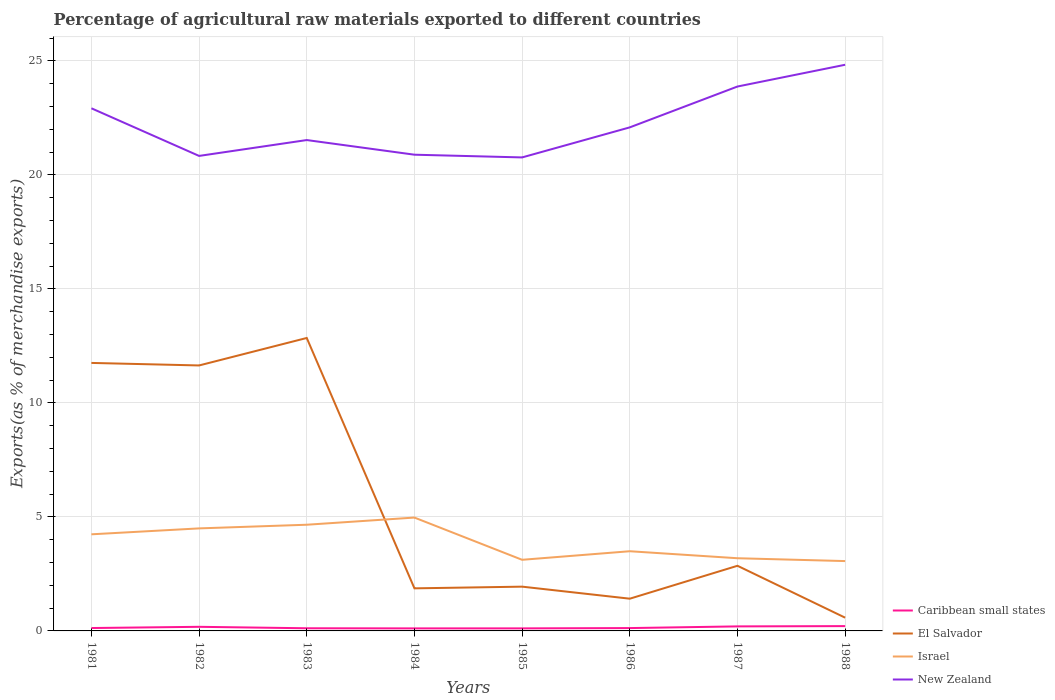Does the line corresponding to Caribbean small states intersect with the line corresponding to Israel?
Make the answer very short. No. Across all years, what is the maximum percentage of exports to different countries in Caribbean small states?
Provide a succinct answer. 0.11. What is the total percentage of exports to different countries in Israel in the graph?
Your answer should be compact. 1.43. What is the difference between the highest and the second highest percentage of exports to different countries in El Salvador?
Provide a short and direct response. 12.27. How many lines are there?
Provide a short and direct response. 4. How many legend labels are there?
Make the answer very short. 4. How are the legend labels stacked?
Keep it short and to the point. Vertical. What is the title of the graph?
Your response must be concise. Percentage of agricultural raw materials exported to different countries. Does "United Arab Emirates" appear as one of the legend labels in the graph?
Your answer should be very brief. No. What is the label or title of the Y-axis?
Make the answer very short. Exports(as % of merchandise exports). What is the Exports(as % of merchandise exports) of Caribbean small states in 1981?
Offer a terse response. 0.13. What is the Exports(as % of merchandise exports) of El Salvador in 1981?
Keep it short and to the point. 11.76. What is the Exports(as % of merchandise exports) in Israel in 1981?
Your answer should be very brief. 4.24. What is the Exports(as % of merchandise exports) of New Zealand in 1981?
Make the answer very short. 22.92. What is the Exports(as % of merchandise exports) of Caribbean small states in 1982?
Ensure brevity in your answer.  0.18. What is the Exports(as % of merchandise exports) in El Salvador in 1982?
Make the answer very short. 11.64. What is the Exports(as % of merchandise exports) in Israel in 1982?
Offer a very short reply. 4.5. What is the Exports(as % of merchandise exports) in New Zealand in 1982?
Provide a succinct answer. 20.84. What is the Exports(as % of merchandise exports) in Caribbean small states in 1983?
Your answer should be very brief. 0.12. What is the Exports(as % of merchandise exports) in El Salvador in 1983?
Offer a very short reply. 12.85. What is the Exports(as % of merchandise exports) in Israel in 1983?
Offer a very short reply. 4.66. What is the Exports(as % of merchandise exports) of New Zealand in 1983?
Ensure brevity in your answer.  21.53. What is the Exports(as % of merchandise exports) in Caribbean small states in 1984?
Keep it short and to the point. 0.11. What is the Exports(as % of merchandise exports) in El Salvador in 1984?
Ensure brevity in your answer.  1.87. What is the Exports(as % of merchandise exports) of Israel in 1984?
Make the answer very short. 4.97. What is the Exports(as % of merchandise exports) of New Zealand in 1984?
Provide a short and direct response. 20.89. What is the Exports(as % of merchandise exports) of Caribbean small states in 1985?
Keep it short and to the point. 0.11. What is the Exports(as % of merchandise exports) in El Salvador in 1985?
Make the answer very short. 1.94. What is the Exports(as % of merchandise exports) in Israel in 1985?
Give a very brief answer. 3.12. What is the Exports(as % of merchandise exports) in New Zealand in 1985?
Provide a succinct answer. 20.77. What is the Exports(as % of merchandise exports) of Caribbean small states in 1986?
Provide a succinct answer. 0.12. What is the Exports(as % of merchandise exports) of El Salvador in 1986?
Your answer should be very brief. 1.41. What is the Exports(as % of merchandise exports) in Israel in 1986?
Give a very brief answer. 3.5. What is the Exports(as % of merchandise exports) of New Zealand in 1986?
Your answer should be very brief. 22.09. What is the Exports(as % of merchandise exports) in Caribbean small states in 1987?
Make the answer very short. 0.2. What is the Exports(as % of merchandise exports) in El Salvador in 1987?
Give a very brief answer. 2.86. What is the Exports(as % of merchandise exports) in Israel in 1987?
Give a very brief answer. 3.19. What is the Exports(as % of merchandise exports) of New Zealand in 1987?
Ensure brevity in your answer.  23.88. What is the Exports(as % of merchandise exports) of Caribbean small states in 1988?
Your answer should be very brief. 0.21. What is the Exports(as % of merchandise exports) of El Salvador in 1988?
Offer a very short reply. 0.58. What is the Exports(as % of merchandise exports) in Israel in 1988?
Offer a very short reply. 3.06. What is the Exports(as % of merchandise exports) of New Zealand in 1988?
Offer a very short reply. 24.83. Across all years, what is the maximum Exports(as % of merchandise exports) in Caribbean small states?
Provide a succinct answer. 0.21. Across all years, what is the maximum Exports(as % of merchandise exports) in El Salvador?
Your answer should be very brief. 12.85. Across all years, what is the maximum Exports(as % of merchandise exports) in Israel?
Your answer should be very brief. 4.97. Across all years, what is the maximum Exports(as % of merchandise exports) of New Zealand?
Your answer should be compact. 24.83. Across all years, what is the minimum Exports(as % of merchandise exports) in Caribbean small states?
Offer a very short reply. 0.11. Across all years, what is the minimum Exports(as % of merchandise exports) in El Salvador?
Your response must be concise. 0.58. Across all years, what is the minimum Exports(as % of merchandise exports) in Israel?
Ensure brevity in your answer.  3.06. Across all years, what is the minimum Exports(as % of merchandise exports) of New Zealand?
Your answer should be compact. 20.77. What is the total Exports(as % of merchandise exports) in Caribbean small states in the graph?
Offer a very short reply. 1.18. What is the total Exports(as % of merchandise exports) of El Salvador in the graph?
Ensure brevity in your answer.  44.91. What is the total Exports(as % of merchandise exports) of Israel in the graph?
Ensure brevity in your answer.  31.23. What is the total Exports(as % of merchandise exports) in New Zealand in the graph?
Make the answer very short. 177.75. What is the difference between the Exports(as % of merchandise exports) of Caribbean small states in 1981 and that in 1982?
Offer a terse response. -0.05. What is the difference between the Exports(as % of merchandise exports) in El Salvador in 1981 and that in 1982?
Give a very brief answer. 0.11. What is the difference between the Exports(as % of merchandise exports) of Israel in 1981 and that in 1982?
Keep it short and to the point. -0.26. What is the difference between the Exports(as % of merchandise exports) of New Zealand in 1981 and that in 1982?
Your answer should be very brief. 2.09. What is the difference between the Exports(as % of merchandise exports) in Caribbean small states in 1981 and that in 1983?
Make the answer very short. 0.01. What is the difference between the Exports(as % of merchandise exports) of El Salvador in 1981 and that in 1983?
Make the answer very short. -1.09. What is the difference between the Exports(as % of merchandise exports) of Israel in 1981 and that in 1983?
Your answer should be compact. -0.42. What is the difference between the Exports(as % of merchandise exports) in New Zealand in 1981 and that in 1983?
Ensure brevity in your answer.  1.39. What is the difference between the Exports(as % of merchandise exports) in Caribbean small states in 1981 and that in 1984?
Offer a terse response. 0.02. What is the difference between the Exports(as % of merchandise exports) of El Salvador in 1981 and that in 1984?
Your answer should be compact. 9.89. What is the difference between the Exports(as % of merchandise exports) of Israel in 1981 and that in 1984?
Your response must be concise. -0.73. What is the difference between the Exports(as % of merchandise exports) of New Zealand in 1981 and that in 1984?
Offer a terse response. 2.04. What is the difference between the Exports(as % of merchandise exports) in Caribbean small states in 1981 and that in 1985?
Provide a succinct answer. 0.02. What is the difference between the Exports(as % of merchandise exports) of El Salvador in 1981 and that in 1985?
Offer a very short reply. 9.81. What is the difference between the Exports(as % of merchandise exports) in Israel in 1981 and that in 1985?
Your answer should be compact. 1.12. What is the difference between the Exports(as % of merchandise exports) in New Zealand in 1981 and that in 1985?
Give a very brief answer. 2.15. What is the difference between the Exports(as % of merchandise exports) of Caribbean small states in 1981 and that in 1986?
Your answer should be very brief. 0. What is the difference between the Exports(as % of merchandise exports) in El Salvador in 1981 and that in 1986?
Give a very brief answer. 10.34. What is the difference between the Exports(as % of merchandise exports) of Israel in 1981 and that in 1986?
Give a very brief answer. 0.74. What is the difference between the Exports(as % of merchandise exports) in New Zealand in 1981 and that in 1986?
Offer a terse response. 0.84. What is the difference between the Exports(as % of merchandise exports) of Caribbean small states in 1981 and that in 1987?
Your answer should be very brief. -0.07. What is the difference between the Exports(as % of merchandise exports) of El Salvador in 1981 and that in 1987?
Give a very brief answer. 8.9. What is the difference between the Exports(as % of merchandise exports) in Israel in 1981 and that in 1987?
Your answer should be very brief. 1.05. What is the difference between the Exports(as % of merchandise exports) of New Zealand in 1981 and that in 1987?
Give a very brief answer. -0.95. What is the difference between the Exports(as % of merchandise exports) of Caribbean small states in 1981 and that in 1988?
Make the answer very short. -0.08. What is the difference between the Exports(as % of merchandise exports) in El Salvador in 1981 and that in 1988?
Ensure brevity in your answer.  11.17. What is the difference between the Exports(as % of merchandise exports) in Israel in 1981 and that in 1988?
Keep it short and to the point. 1.17. What is the difference between the Exports(as % of merchandise exports) in New Zealand in 1981 and that in 1988?
Make the answer very short. -1.91. What is the difference between the Exports(as % of merchandise exports) of Caribbean small states in 1982 and that in 1983?
Give a very brief answer. 0.06. What is the difference between the Exports(as % of merchandise exports) of El Salvador in 1982 and that in 1983?
Offer a terse response. -1.21. What is the difference between the Exports(as % of merchandise exports) of Israel in 1982 and that in 1983?
Your response must be concise. -0.16. What is the difference between the Exports(as % of merchandise exports) in New Zealand in 1982 and that in 1983?
Offer a terse response. -0.7. What is the difference between the Exports(as % of merchandise exports) of Caribbean small states in 1982 and that in 1984?
Your response must be concise. 0.07. What is the difference between the Exports(as % of merchandise exports) in El Salvador in 1982 and that in 1984?
Ensure brevity in your answer.  9.78. What is the difference between the Exports(as % of merchandise exports) of Israel in 1982 and that in 1984?
Give a very brief answer. -0.47. What is the difference between the Exports(as % of merchandise exports) in New Zealand in 1982 and that in 1984?
Provide a succinct answer. -0.05. What is the difference between the Exports(as % of merchandise exports) of Caribbean small states in 1982 and that in 1985?
Your answer should be compact. 0.07. What is the difference between the Exports(as % of merchandise exports) in El Salvador in 1982 and that in 1985?
Keep it short and to the point. 9.7. What is the difference between the Exports(as % of merchandise exports) of Israel in 1982 and that in 1985?
Provide a succinct answer. 1.38. What is the difference between the Exports(as % of merchandise exports) in New Zealand in 1982 and that in 1985?
Offer a very short reply. 0.07. What is the difference between the Exports(as % of merchandise exports) in Caribbean small states in 1982 and that in 1986?
Offer a very short reply. 0.06. What is the difference between the Exports(as % of merchandise exports) in El Salvador in 1982 and that in 1986?
Offer a very short reply. 10.23. What is the difference between the Exports(as % of merchandise exports) in Israel in 1982 and that in 1986?
Offer a terse response. 1. What is the difference between the Exports(as % of merchandise exports) of New Zealand in 1982 and that in 1986?
Provide a short and direct response. -1.25. What is the difference between the Exports(as % of merchandise exports) in Caribbean small states in 1982 and that in 1987?
Provide a succinct answer. -0.02. What is the difference between the Exports(as % of merchandise exports) in El Salvador in 1982 and that in 1987?
Ensure brevity in your answer.  8.79. What is the difference between the Exports(as % of merchandise exports) of Israel in 1982 and that in 1987?
Your answer should be compact. 1.31. What is the difference between the Exports(as % of merchandise exports) in New Zealand in 1982 and that in 1987?
Keep it short and to the point. -3.04. What is the difference between the Exports(as % of merchandise exports) of Caribbean small states in 1982 and that in 1988?
Offer a terse response. -0.03. What is the difference between the Exports(as % of merchandise exports) of El Salvador in 1982 and that in 1988?
Your response must be concise. 11.06. What is the difference between the Exports(as % of merchandise exports) in Israel in 1982 and that in 1988?
Your answer should be compact. 1.43. What is the difference between the Exports(as % of merchandise exports) of New Zealand in 1982 and that in 1988?
Provide a succinct answer. -4. What is the difference between the Exports(as % of merchandise exports) in Caribbean small states in 1983 and that in 1984?
Give a very brief answer. 0.01. What is the difference between the Exports(as % of merchandise exports) in El Salvador in 1983 and that in 1984?
Make the answer very short. 10.98. What is the difference between the Exports(as % of merchandise exports) of Israel in 1983 and that in 1984?
Give a very brief answer. -0.31. What is the difference between the Exports(as % of merchandise exports) in New Zealand in 1983 and that in 1984?
Keep it short and to the point. 0.64. What is the difference between the Exports(as % of merchandise exports) of Caribbean small states in 1983 and that in 1985?
Keep it short and to the point. 0. What is the difference between the Exports(as % of merchandise exports) of El Salvador in 1983 and that in 1985?
Ensure brevity in your answer.  10.91. What is the difference between the Exports(as % of merchandise exports) of Israel in 1983 and that in 1985?
Give a very brief answer. 1.54. What is the difference between the Exports(as % of merchandise exports) of New Zealand in 1983 and that in 1985?
Your response must be concise. 0.76. What is the difference between the Exports(as % of merchandise exports) in Caribbean small states in 1983 and that in 1986?
Offer a terse response. -0.01. What is the difference between the Exports(as % of merchandise exports) of El Salvador in 1983 and that in 1986?
Give a very brief answer. 11.44. What is the difference between the Exports(as % of merchandise exports) of Israel in 1983 and that in 1986?
Keep it short and to the point. 1.16. What is the difference between the Exports(as % of merchandise exports) in New Zealand in 1983 and that in 1986?
Offer a very short reply. -0.56. What is the difference between the Exports(as % of merchandise exports) of Caribbean small states in 1983 and that in 1987?
Offer a terse response. -0.08. What is the difference between the Exports(as % of merchandise exports) in El Salvador in 1983 and that in 1987?
Offer a very short reply. 9.99. What is the difference between the Exports(as % of merchandise exports) of Israel in 1983 and that in 1987?
Offer a very short reply. 1.47. What is the difference between the Exports(as % of merchandise exports) in New Zealand in 1983 and that in 1987?
Your answer should be very brief. -2.35. What is the difference between the Exports(as % of merchandise exports) of Caribbean small states in 1983 and that in 1988?
Offer a terse response. -0.09. What is the difference between the Exports(as % of merchandise exports) in El Salvador in 1983 and that in 1988?
Your response must be concise. 12.27. What is the difference between the Exports(as % of merchandise exports) in Israel in 1983 and that in 1988?
Make the answer very short. 1.59. What is the difference between the Exports(as % of merchandise exports) in New Zealand in 1983 and that in 1988?
Offer a very short reply. -3.3. What is the difference between the Exports(as % of merchandise exports) of Caribbean small states in 1984 and that in 1985?
Ensure brevity in your answer.  -0. What is the difference between the Exports(as % of merchandise exports) in El Salvador in 1984 and that in 1985?
Your answer should be compact. -0.07. What is the difference between the Exports(as % of merchandise exports) of Israel in 1984 and that in 1985?
Your answer should be compact. 1.85. What is the difference between the Exports(as % of merchandise exports) of New Zealand in 1984 and that in 1985?
Offer a very short reply. 0.12. What is the difference between the Exports(as % of merchandise exports) in Caribbean small states in 1984 and that in 1986?
Provide a succinct answer. -0.01. What is the difference between the Exports(as % of merchandise exports) in El Salvador in 1984 and that in 1986?
Your answer should be very brief. 0.45. What is the difference between the Exports(as % of merchandise exports) in Israel in 1984 and that in 1986?
Give a very brief answer. 1.48. What is the difference between the Exports(as % of merchandise exports) in New Zealand in 1984 and that in 1986?
Your response must be concise. -1.2. What is the difference between the Exports(as % of merchandise exports) in Caribbean small states in 1984 and that in 1987?
Provide a succinct answer. -0.09. What is the difference between the Exports(as % of merchandise exports) in El Salvador in 1984 and that in 1987?
Your response must be concise. -0.99. What is the difference between the Exports(as % of merchandise exports) of Israel in 1984 and that in 1987?
Provide a short and direct response. 1.78. What is the difference between the Exports(as % of merchandise exports) in New Zealand in 1984 and that in 1987?
Ensure brevity in your answer.  -2.99. What is the difference between the Exports(as % of merchandise exports) in Caribbean small states in 1984 and that in 1988?
Make the answer very short. -0.1. What is the difference between the Exports(as % of merchandise exports) of El Salvador in 1984 and that in 1988?
Make the answer very short. 1.29. What is the difference between the Exports(as % of merchandise exports) in Israel in 1984 and that in 1988?
Provide a succinct answer. 1.91. What is the difference between the Exports(as % of merchandise exports) of New Zealand in 1984 and that in 1988?
Offer a terse response. -3.95. What is the difference between the Exports(as % of merchandise exports) in Caribbean small states in 1985 and that in 1986?
Make the answer very short. -0.01. What is the difference between the Exports(as % of merchandise exports) of El Salvador in 1985 and that in 1986?
Provide a short and direct response. 0.53. What is the difference between the Exports(as % of merchandise exports) of Israel in 1985 and that in 1986?
Provide a succinct answer. -0.38. What is the difference between the Exports(as % of merchandise exports) of New Zealand in 1985 and that in 1986?
Offer a very short reply. -1.32. What is the difference between the Exports(as % of merchandise exports) of Caribbean small states in 1985 and that in 1987?
Make the answer very short. -0.09. What is the difference between the Exports(as % of merchandise exports) in El Salvador in 1985 and that in 1987?
Your answer should be very brief. -0.92. What is the difference between the Exports(as % of merchandise exports) in Israel in 1985 and that in 1987?
Offer a very short reply. -0.07. What is the difference between the Exports(as % of merchandise exports) in New Zealand in 1985 and that in 1987?
Give a very brief answer. -3.11. What is the difference between the Exports(as % of merchandise exports) of Caribbean small states in 1985 and that in 1988?
Make the answer very short. -0.1. What is the difference between the Exports(as % of merchandise exports) in El Salvador in 1985 and that in 1988?
Your answer should be compact. 1.36. What is the difference between the Exports(as % of merchandise exports) in Israel in 1985 and that in 1988?
Your response must be concise. 0.06. What is the difference between the Exports(as % of merchandise exports) in New Zealand in 1985 and that in 1988?
Ensure brevity in your answer.  -4.06. What is the difference between the Exports(as % of merchandise exports) of Caribbean small states in 1986 and that in 1987?
Give a very brief answer. -0.07. What is the difference between the Exports(as % of merchandise exports) of El Salvador in 1986 and that in 1987?
Offer a terse response. -1.44. What is the difference between the Exports(as % of merchandise exports) of Israel in 1986 and that in 1987?
Your answer should be very brief. 0.31. What is the difference between the Exports(as % of merchandise exports) in New Zealand in 1986 and that in 1987?
Offer a very short reply. -1.79. What is the difference between the Exports(as % of merchandise exports) of Caribbean small states in 1986 and that in 1988?
Provide a succinct answer. -0.09. What is the difference between the Exports(as % of merchandise exports) of El Salvador in 1986 and that in 1988?
Ensure brevity in your answer.  0.83. What is the difference between the Exports(as % of merchandise exports) of Israel in 1986 and that in 1988?
Your answer should be very brief. 0.43. What is the difference between the Exports(as % of merchandise exports) of New Zealand in 1986 and that in 1988?
Give a very brief answer. -2.75. What is the difference between the Exports(as % of merchandise exports) in Caribbean small states in 1987 and that in 1988?
Provide a succinct answer. -0.01. What is the difference between the Exports(as % of merchandise exports) of El Salvador in 1987 and that in 1988?
Give a very brief answer. 2.28. What is the difference between the Exports(as % of merchandise exports) of Israel in 1987 and that in 1988?
Provide a succinct answer. 0.12. What is the difference between the Exports(as % of merchandise exports) in New Zealand in 1987 and that in 1988?
Offer a terse response. -0.95. What is the difference between the Exports(as % of merchandise exports) in Caribbean small states in 1981 and the Exports(as % of merchandise exports) in El Salvador in 1982?
Offer a very short reply. -11.52. What is the difference between the Exports(as % of merchandise exports) in Caribbean small states in 1981 and the Exports(as % of merchandise exports) in Israel in 1982?
Provide a succinct answer. -4.37. What is the difference between the Exports(as % of merchandise exports) of Caribbean small states in 1981 and the Exports(as % of merchandise exports) of New Zealand in 1982?
Make the answer very short. -20.71. What is the difference between the Exports(as % of merchandise exports) in El Salvador in 1981 and the Exports(as % of merchandise exports) in Israel in 1982?
Provide a succinct answer. 7.26. What is the difference between the Exports(as % of merchandise exports) in El Salvador in 1981 and the Exports(as % of merchandise exports) in New Zealand in 1982?
Provide a succinct answer. -9.08. What is the difference between the Exports(as % of merchandise exports) in Israel in 1981 and the Exports(as % of merchandise exports) in New Zealand in 1982?
Give a very brief answer. -16.6. What is the difference between the Exports(as % of merchandise exports) of Caribbean small states in 1981 and the Exports(as % of merchandise exports) of El Salvador in 1983?
Your answer should be compact. -12.72. What is the difference between the Exports(as % of merchandise exports) of Caribbean small states in 1981 and the Exports(as % of merchandise exports) of Israel in 1983?
Make the answer very short. -4.53. What is the difference between the Exports(as % of merchandise exports) in Caribbean small states in 1981 and the Exports(as % of merchandise exports) in New Zealand in 1983?
Make the answer very short. -21.4. What is the difference between the Exports(as % of merchandise exports) in El Salvador in 1981 and the Exports(as % of merchandise exports) in Israel in 1983?
Your answer should be very brief. 7.1. What is the difference between the Exports(as % of merchandise exports) of El Salvador in 1981 and the Exports(as % of merchandise exports) of New Zealand in 1983?
Ensure brevity in your answer.  -9.78. What is the difference between the Exports(as % of merchandise exports) of Israel in 1981 and the Exports(as % of merchandise exports) of New Zealand in 1983?
Your answer should be very brief. -17.29. What is the difference between the Exports(as % of merchandise exports) of Caribbean small states in 1981 and the Exports(as % of merchandise exports) of El Salvador in 1984?
Your answer should be very brief. -1.74. What is the difference between the Exports(as % of merchandise exports) in Caribbean small states in 1981 and the Exports(as % of merchandise exports) in Israel in 1984?
Provide a succinct answer. -4.85. What is the difference between the Exports(as % of merchandise exports) in Caribbean small states in 1981 and the Exports(as % of merchandise exports) in New Zealand in 1984?
Offer a very short reply. -20.76. What is the difference between the Exports(as % of merchandise exports) in El Salvador in 1981 and the Exports(as % of merchandise exports) in Israel in 1984?
Your response must be concise. 6.78. What is the difference between the Exports(as % of merchandise exports) of El Salvador in 1981 and the Exports(as % of merchandise exports) of New Zealand in 1984?
Provide a succinct answer. -9.13. What is the difference between the Exports(as % of merchandise exports) in Israel in 1981 and the Exports(as % of merchandise exports) in New Zealand in 1984?
Ensure brevity in your answer.  -16.65. What is the difference between the Exports(as % of merchandise exports) of Caribbean small states in 1981 and the Exports(as % of merchandise exports) of El Salvador in 1985?
Give a very brief answer. -1.82. What is the difference between the Exports(as % of merchandise exports) in Caribbean small states in 1981 and the Exports(as % of merchandise exports) in Israel in 1985?
Provide a succinct answer. -2.99. What is the difference between the Exports(as % of merchandise exports) of Caribbean small states in 1981 and the Exports(as % of merchandise exports) of New Zealand in 1985?
Offer a very short reply. -20.64. What is the difference between the Exports(as % of merchandise exports) of El Salvador in 1981 and the Exports(as % of merchandise exports) of Israel in 1985?
Give a very brief answer. 8.64. What is the difference between the Exports(as % of merchandise exports) of El Salvador in 1981 and the Exports(as % of merchandise exports) of New Zealand in 1985?
Offer a very short reply. -9.01. What is the difference between the Exports(as % of merchandise exports) of Israel in 1981 and the Exports(as % of merchandise exports) of New Zealand in 1985?
Your answer should be compact. -16.53. What is the difference between the Exports(as % of merchandise exports) of Caribbean small states in 1981 and the Exports(as % of merchandise exports) of El Salvador in 1986?
Your answer should be compact. -1.29. What is the difference between the Exports(as % of merchandise exports) of Caribbean small states in 1981 and the Exports(as % of merchandise exports) of Israel in 1986?
Provide a short and direct response. -3.37. What is the difference between the Exports(as % of merchandise exports) in Caribbean small states in 1981 and the Exports(as % of merchandise exports) in New Zealand in 1986?
Make the answer very short. -21.96. What is the difference between the Exports(as % of merchandise exports) of El Salvador in 1981 and the Exports(as % of merchandise exports) of Israel in 1986?
Provide a short and direct response. 8.26. What is the difference between the Exports(as % of merchandise exports) of El Salvador in 1981 and the Exports(as % of merchandise exports) of New Zealand in 1986?
Offer a terse response. -10.33. What is the difference between the Exports(as % of merchandise exports) of Israel in 1981 and the Exports(as % of merchandise exports) of New Zealand in 1986?
Give a very brief answer. -17.85. What is the difference between the Exports(as % of merchandise exports) of Caribbean small states in 1981 and the Exports(as % of merchandise exports) of El Salvador in 1987?
Offer a very short reply. -2.73. What is the difference between the Exports(as % of merchandise exports) of Caribbean small states in 1981 and the Exports(as % of merchandise exports) of Israel in 1987?
Make the answer very short. -3.06. What is the difference between the Exports(as % of merchandise exports) in Caribbean small states in 1981 and the Exports(as % of merchandise exports) in New Zealand in 1987?
Your response must be concise. -23.75. What is the difference between the Exports(as % of merchandise exports) of El Salvador in 1981 and the Exports(as % of merchandise exports) of Israel in 1987?
Keep it short and to the point. 8.57. What is the difference between the Exports(as % of merchandise exports) in El Salvador in 1981 and the Exports(as % of merchandise exports) in New Zealand in 1987?
Offer a terse response. -12.12. What is the difference between the Exports(as % of merchandise exports) of Israel in 1981 and the Exports(as % of merchandise exports) of New Zealand in 1987?
Give a very brief answer. -19.64. What is the difference between the Exports(as % of merchandise exports) of Caribbean small states in 1981 and the Exports(as % of merchandise exports) of El Salvador in 1988?
Provide a succinct answer. -0.45. What is the difference between the Exports(as % of merchandise exports) of Caribbean small states in 1981 and the Exports(as % of merchandise exports) of Israel in 1988?
Keep it short and to the point. -2.94. What is the difference between the Exports(as % of merchandise exports) in Caribbean small states in 1981 and the Exports(as % of merchandise exports) in New Zealand in 1988?
Ensure brevity in your answer.  -24.71. What is the difference between the Exports(as % of merchandise exports) of El Salvador in 1981 and the Exports(as % of merchandise exports) of Israel in 1988?
Ensure brevity in your answer.  8.69. What is the difference between the Exports(as % of merchandise exports) of El Salvador in 1981 and the Exports(as % of merchandise exports) of New Zealand in 1988?
Give a very brief answer. -13.08. What is the difference between the Exports(as % of merchandise exports) in Israel in 1981 and the Exports(as % of merchandise exports) in New Zealand in 1988?
Ensure brevity in your answer.  -20.6. What is the difference between the Exports(as % of merchandise exports) in Caribbean small states in 1982 and the Exports(as % of merchandise exports) in El Salvador in 1983?
Ensure brevity in your answer.  -12.67. What is the difference between the Exports(as % of merchandise exports) in Caribbean small states in 1982 and the Exports(as % of merchandise exports) in Israel in 1983?
Offer a terse response. -4.48. What is the difference between the Exports(as % of merchandise exports) in Caribbean small states in 1982 and the Exports(as % of merchandise exports) in New Zealand in 1983?
Give a very brief answer. -21.35. What is the difference between the Exports(as % of merchandise exports) in El Salvador in 1982 and the Exports(as % of merchandise exports) in Israel in 1983?
Offer a terse response. 6.99. What is the difference between the Exports(as % of merchandise exports) of El Salvador in 1982 and the Exports(as % of merchandise exports) of New Zealand in 1983?
Keep it short and to the point. -9.89. What is the difference between the Exports(as % of merchandise exports) in Israel in 1982 and the Exports(as % of merchandise exports) in New Zealand in 1983?
Keep it short and to the point. -17.03. What is the difference between the Exports(as % of merchandise exports) of Caribbean small states in 1982 and the Exports(as % of merchandise exports) of El Salvador in 1984?
Offer a very short reply. -1.69. What is the difference between the Exports(as % of merchandise exports) of Caribbean small states in 1982 and the Exports(as % of merchandise exports) of Israel in 1984?
Make the answer very short. -4.79. What is the difference between the Exports(as % of merchandise exports) in Caribbean small states in 1982 and the Exports(as % of merchandise exports) in New Zealand in 1984?
Provide a succinct answer. -20.71. What is the difference between the Exports(as % of merchandise exports) in El Salvador in 1982 and the Exports(as % of merchandise exports) in Israel in 1984?
Provide a succinct answer. 6.67. What is the difference between the Exports(as % of merchandise exports) in El Salvador in 1982 and the Exports(as % of merchandise exports) in New Zealand in 1984?
Keep it short and to the point. -9.24. What is the difference between the Exports(as % of merchandise exports) in Israel in 1982 and the Exports(as % of merchandise exports) in New Zealand in 1984?
Offer a terse response. -16.39. What is the difference between the Exports(as % of merchandise exports) in Caribbean small states in 1982 and the Exports(as % of merchandise exports) in El Salvador in 1985?
Provide a succinct answer. -1.76. What is the difference between the Exports(as % of merchandise exports) of Caribbean small states in 1982 and the Exports(as % of merchandise exports) of Israel in 1985?
Offer a very short reply. -2.94. What is the difference between the Exports(as % of merchandise exports) of Caribbean small states in 1982 and the Exports(as % of merchandise exports) of New Zealand in 1985?
Offer a terse response. -20.59. What is the difference between the Exports(as % of merchandise exports) of El Salvador in 1982 and the Exports(as % of merchandise exports) of Israel in 1985?
Offer a very short reply. 8.52. What is the difference between the Exports(as % of merchandise exports) in El Salvador in 1982 and the Exports(as % of merchandise exports) in New Zealand in 1985?
Your answer should be compact. -9.12. What is the difference between the Exports(as % of merchandise exports) of Israel in 1982 and the Exports(as % of merchandise exports) of New Zealand in 1985?
Keep it short and to the point. -16.27. What is the difference between the Exports(as % of merchandise exports) in Caribbean small states in 1982 and the Exports(as % of merchandise exports) in El Salvador in 1986?
Provide a short and direct response. -1.23. What is the difference between the Exports(as % of merchandise exports) of Caribbean small states in 1982 and the Exports(as % of merchandise exports) of Israel in 1986?
Your answer should be very brief. -3.31. What is the difference between the Exports(as % of merchandise exports) in Caribbean small states in 1982 and the Exports(as % of merchandise exports) in New Zealand in 1986?
Keep it short and to the point. -21.91. What is the difference between the Exports(as % of merchandise exports) of El Salvador in 1982 and the Exports(as % of merchandise exports) of Israel in 1986?
Provide a short and direct response. 8.15. What is the difference between the Exports(as % of merchandise exports) of El Salvador in 1982 and the Exports(as % of merchandise exports) of New Zealand in 1986?
Your answer should be very brief. -10.44. What is the difference between the Exports(as % of merchandise exports) of Israel in 1982 and the Exports(as % of merchandise exports) of New Zealand in 1986?
Provide a succinct answer. -17.59. What is the difference between the Exports(as % of merchandise exports) in Caribbean small states in 1982 and the Exports(as % of merchandise exports) in El Salvador in 1987?
Give a very brief answer. -2.68. What is the difference between the Exports(as % of merchandise exports) in Caribbean small states in 1982 and the Exports(as % of merchandise exports) in Israel in 1987?
Your answer should be compact. -3.01. What is the difference between the Exports(as % of merchandise exports) in Caribbean small states in 1982 and the Exports(as % of merchandise exports) in New Zealand in 1987?
Keep it short and to the point. -23.7. What is the difference between the Exports(as % of merchandise exports) of El Salvador in 1982 and the Exports(as % of merchandise exports) of Israel in 1987?
Your answer should be very brief. 8.46. What is the difference between the Exports(as % of merchandise exports) in El Salvador in 1982 and the Exports(as % of merchandise exports) in New Zealand in 1987?
Ensure brevity in your answer.  -12.23. What is the difference between the Exports(as % of merchandise exports) of Israel in 1982 and the Exports(as % of merchandise exports) of New Zealand in 1987?
Your answer should be very brief. -19.38. What is the difference between the Exports(as % of merchandise exports) of Caribbean small states in 1982 and the Exports(as % of merchandise exports) of El Salvador in 1988?
Ensure brevity in your answer.  -0.4. What is the difference between the Exports(as % of merchandise exports) in Caribbean small states in 1982 and the Exports(as % of merchandise exports) in Israel in 1988?
Make the answer very short. -2.88. What is the difference between the Exports(as % of merchandise exports) of Caribbean small states in 1982 and the Exports(as % of merchandise exports) of New Zealand in 1988?
Give a very brief answer. -24.65. What is the difference between the Exports(as % of merchandise exports) of El Salvador in 1982 and the Exports(as % of merchandise exports) of Israel in 1988?
Your response must be concise. 8.58. What is the difference between the Exports(as % of merchandise exports) in El Salvador in 1982 and the Exports(as % of merchandise exports) in New Zealand in 1988?
Provide a succinct answer. -13.19. What is the difference between the Exports(as % of merchandise exports) in Israel in 1982 and the Exports(as % of merchandise exports) in New Zealand in 1988?
Offer a very short reply. -20.34. What is the difference between the Exports(as % of merchandise exports) in Caribbean small states in 1983 and the Exports(as % of merchandise exports) in El Salvador in 1984?
Provide a short and direct response. -1.75. What is the difference between the Exports(as % of merchandise exports) of Caribbean small states in 1983 and the Exports(as % of merchandise exports) of Israel in 1984?
Offer a terse response. -4.86. What is the difference between the Exports(as % of merchandise exports) in Caribbean small states in 1983 and the Exports(as % of merchandise exports) in New Zealand in 1984?
Give a very brief answer. -20.77. What is the difference between the Exports(as % of merchandise exports) of El Salvador in 1983 and the Exports(as % of merchandise exports) of Israel in 1984?
Provide a short and direct response. 7.88. What is the difference between the Exports(as % of merchandise exports) in El Salvador in 1983 and the Exports(as % of merchandise exports) in New Zealand in 1984?
Your answer should be very brief. -8.04. What is the difference between the Exports(as % of merchandise exports) in Israel in 1983 and the Exports(as % of merchandise exports) in New Zealand in 1984?
Your answer should be compact. -16.23. What is the difference between the Exports(as % of merchandise exports) of Caribbean small states in 1983 and the Exports(as % of merchandise exports) of El Salvador in 1985?
Provide a succinct answer. -1.83. What is the difference between the Exports(as % of merchandise exports) in Caribbean small states in 1983 and the Exports(as % of merchandise exports) in Israel in 1985?
Give a very brief answer. -3. What is the difference between the Exports(as % of merchandise exports) in Caribbean small states in 1983 and the Exports(as % of merchandise exports) in New Zealand in 1985?
Your response must be concise. -20.65. What is the difference between the Exports(as % of merchandise exports) of El Salvador in 1983 and the Exports(as % of merchandise exports) of Israel in 1985?
Provide a succinct answer. 9.73. What is the difference between the Exports(as % of merchandise exports) in El Salvador in 1983 and the Exports(as % of merchandise exports) in New Zealand in 1985?
Ensure brevity in your answer.  -7.92. What is the difference between the Exports(as % of merchandise exports) in Israel in 1983 and the Exports(as % of merchandise exports) in New Zealand in 1985?
Make the answer very short. -16.11. What is the difference between the Exports(as % of merchandise exports) in Caribbean small states in 1983 and the Exports(as % of merchandise exports) in El Salvador in 1986?
Offer a very short reply. -1.3. What is the difference between the Exports(as % of merchandise exports) of Caribbean small states in 1983 and the Exports(as % of merchandise exports) of Israel in 1986?
Ensure brevity in your answer.  -3.38. What is the difference between the Exports(as % of merchandise exports) of Caribbean small states in 1983 and the Exports(as % of merchandise exports) of New Zealand in 1986?
Provide a short and direct response. -21.97. What is the difference between the Exports(as % of merchandise exports) in El Salvador in 1983 and the Exports(as % of merchandise exports) in Israel in 1986?
Ensure brevity in your answer.  9.35. What is the difference between the Exports(as % of merchandise exports) of El Salvador in 1983 and the Exports(as % of merchandise exports) of New Zealand in 1986?
Provide a succinct answer. -9.24. What is the difference between the Exports(as % of merchandise exports) of Israel in 1983 and the Exports(as % of merchandise exports) of New Zealand in 1986?
Your answer should be very brief. -17.43. What is the difference between the Exports(as % of merchandise exports) in Caribbean small states in 1983 and the Exports(as % of merchandise exports) in El Salvador in 1987?
Provide a succinct answer. -2.74. What is the difference between the Exports(as % of merchandise exports) of Caribbean small states in 1983 and the Exports(as % of merchandise exports) of Israel in 1987?
Keep it short and to the point. -3.07. What is the difference between the Exports(as % of merchandise exports) in Caribbean small states in 1983 and the Exports(as % of merchandise exports) in New Zealand in 1987?
Your answer should be compact. -23.76. What is the difference between the Exports(as % of merchandise exports) in El Salvador in 1983 and the Exports(as % of merchandise exports) in Israel in 1987?
Give a very brief answer. 9.66. What is the difference between the Exports(as % of merchandise exports) of El Salvador in 1983 and the Exports(as % of merchandise exports) of New Zealand in 1987?
Keep it short and to the point. -11.03. What is the difference between the Exports(as % of merchandise exports) of Israel in 1983 and the Exports(as % of merchandise exports) of New Zealand in 1987?
Ensure brevity in your answer.  -19.22. What is the difference between the Exports(as % of merchandise exports) in Caribbean small states in 1983 and the Exports(as % of merchandise exports) in El Salvador in 1988?
Provide a short and direct response. -0.46. What is the difference between the Exports(as % of merchandise exports) in Caribbean small states in 1983 and the Exports(as % of merchandise exports) in Israel in 1988?
Your answer should be compact. -2.95. What is the difference between the Exports(as % of merchandise exports) of Caribbean small states in 1983 and the Exports(as % of merchandise exports) of New Zealand in 1988?
Make the answer very short. -24.72. What is the difference between the Exports(as % of merchandise exports) in El Salvador in 1983 and the Exports(as % of merchandise exports) in Israel in 1988?
Your answer should be very brief. 9.79. What is the difference between the Exports(as % of merchandise exports) of El Salvador in 1983 and the Exports(as % of merchandise exports) of New Zealand in 1988?
Your response must be concise. -11.98. What is the difference between the Exports(as % of merchandise exports) of Israel in 1983 and the Exports(as % of merchandise exports) of New Zealand in 1988?
Your answer should be compact. -20.18. What is the difference between the Exports(as % of merchandise exports) of Caribbean small states in 1984 and the Exports(as % of merchandise exports) of El Salvador in 1985?
Provide a succinct answer. -1.83. What is the difference between the Exports(as % of merchandise exports) in Caribbean small states in 1984 and the Exports(as % of merchandise exports) in Israel in 1985?
Offer a terse response. -3.01. What is the difference between the Exports(as % of merchandise exports) in Caribbean small states in 1984 and the Exports(as % of merchandise exports) in New Zealand in 1985?
Make the answer very short. -20.66. What is the difference between the Exports(as % of merchandise exports) of El Salvador in 1984 and the Exports(as % of merchandise exports) of Israel in 1985?
Offer a very short reply. -1.25. What is the difference between the Exports(as % of merchandise exports) in El Salvador in 1984 and the Exports(as % of merchandise exports) in New Zealand in 1985?
Provide a short and direct response. -18.9. What is the difference between the Exports(as % of merchandise exports) of Israel in 1984 and the Exports(as % of merchandise exports) of New Zealand in 1985?
Your response must be concise. -15.8. What is the difference between the Exports(as % of merchandise exports) in Caribbean small states in 1984 and the Exports(as % of merchandise exports) in El Salvador in 1986?
Keep it short and to the point. -1.3. What is the difference between the Exports(as % of merchandise exports) in Caribbean small states in 1984 and the Exports(as % of merchandise exports) in Israel in 1986?
Offer a terse response. -3.38. What is the difference between the Exports(as % of merchandise exports) in Caribbean small states in 1984 and the Exports(as % of merchandise exports) in New Zealand in 1986?
Make the answer very short. -21.98. What is the difference between the Exports(as % of merchandise exports) of El Salvador in 1984 and the Exports(as % of merchandise exports) of Israel in 1986?
Make the answer very short. -1.63. What is the difference between the Exports(as % of merchandise exports) in El Salvador in 1984 and the Exports(as % of merchandise exports) in New Zealand in 1986?
Ensure brevity in your answer.  -20.22. What is the difference between the Exports(as % of merchandise exports) of Israel in 1984 and the Exports(as % of merchandise exports) of New Zealand in 1986?
Your answer should be compact. -17.12. What is the difference between the Exports(as % of merchandise exports) in Caribbean small states in 1984 and the Exports(as % of merchandise exports) in El Salvador in 1987?
Offer a terse response. -2.75. What is the difference between the Exports(as % of merchandise exports) of Caribbean small states in 1984 and the Exports(as % of merchandise exports) of Israel in 1987?
Provide a succinct answer. -3.08. What is the difference between the Exports(as % of merchandise exports) of Caribbean small states in 1984 and the Exports(as % of merchandise exports) of New Zealand in 1987?
Give a very brief answer. -23.77. What is the difference between the Exports(as % of merchandise exports) in El Salvador in 1984 and the Exports(as % of merchandise exports) in Israel in 1987?
Provide a succinct answer. -1.32. What is the difference between the Exports(as % of merchandise exports) in El Salvador in 1984 and the Exports(as % of merchandise exports) in New Zealand in 1987?
Make the answer very short. -22.01. What is the difference between the Exports(as % of merchandise exports) in Israel in 1984 and the Exports(as % of merchandise exports) in New Zealand in 1987?
Keep it short and to the point. -18.91. What is the difference between the Exports(as % of merchandise exports) of Caribbean small states in 1984 and the Exports(as % of merchandise exports) of El Salvador in 1988?
Your response must be concise. -0.47. What is the difference between the Exports(as % of merchandise exports) of Caribbean small states in 1984 and the Exports(as % of merchandise exports) of Israel in 1988?
Offer a terse response. -2.95. What is the difference between the Exports(as % of merchandise exports) of Caribbean small states in 1984 and the Exports(as % of merchandise exports) of New Zealand in 1988?
Your answer should be very brief. -24.72. What is the difference between the Exports(as % of merchandise exports) of El Salvador in 1984 and the Exports(as % of merchandise exports) of Israel in 1988?
Offer a terse response. -1.2. What is the difference between the Exports(as % of merchandise exports) of El Salvador in 1984 and the Exports(as % of merchandise exports) of New Zealand in 1988?
Your answer should be compact. -22.97. What is the difference between the Exports(as % of merchandise exports) of Israel in 1984 and the Exports(as % of merchandise exports) of New Zealand in 1988?
Offer a very short reply. -19.86. What is the difference between the Exports(as % of merchandise exports) of Caribbean small states in 1985 and the Exports(as % of merchandise exports) of El Salvador in 1986?
Make the answer very short. -1.3. What is the difference between the Exports(as % of merchandise exports) in Caribbean small states in 1985 and the Exports(as % of merchandise exports) in Israel in 1986?
Your response must be concise. -3.38. What is the difference between the Exports(as % of merchandise exports) of Caribbean small states in 1985 and the Exports(as % of merchandise exports) of New Zealand in 1986?
Give a very brief answer. -21.98. What is the difference between the Exports(as % of merchandise exports) in El Salvador in 1985 and the Exports(as % of merchandise exports) in Israel in 1986?
Your answer should be compact. -1.55. What is the difference between the Exports(as % of merchandise exports) of El Salvador in 1985 and the Exports(as % of merchandise exports) of New Zealand in 1986?
Give a very brief answer. -20.15. What is the difference between the Exports(as % of merchandise exports) in Israel in 1985 and the Exports(as % of merchandise exports) in New Zealand in 1986?
Make the answer very short. -18.97. What is the difference between the Exports(as % of merchandise exports) in Caribbean small states in 1985 and the Exports(as % of merchandise exports) in El Salvador in 1987?
Keep it short and to the point. -2.75. What is the difference between the Exports(as % of merchandise exports) of Caribbean small states in 1985 and the Exports(as % of merchandise exports) of Israel in 1987?
Ensure brevity in your answer.  -3.08. What is the difference between the Exports(as % of merchandise exports) in Caribbean small states in 1985 and the Exports(as % of merchandise exports) in New Zealand in 1987?
Your response must be concise. -23.77. What is the difference between the Exports(as % of merchandise exports) in El Salvador in 1985 and the Exports(as % of merchandise exports) in Israel in 1987?
Your answer should be compact. -1.25. What is the difference between the Exports(as % of merchandise exports) of El Salvador in 1985 and the Exports(as % of merchandise exports) of New Zealand in 1987?
Offer a very short reply. -21.94. What is the difference between the Exports(as % of merchandise exports) of Israel in 1985 and the Exports(as % of merchandise exports) of New Zealand in 1987?
Ensure brevity in your answer.  -20.76. What is the difference between the Exports(as % of merchandise exports) of Caribbean small states in 1985 and the Exports(as % of merchandise exports) of El Salvador in 1988?
Give a very brief answer. -0.47. What is the difference between the Exports(as % of merchandise exports) of Caribbean small states in 1985 and the Exports(as % of merchandise exports) of Israel in 1988?
Your response must be concise. -2.95. What is the difference between the Exports(as % of merchandise exports) of Caribbean small states in 1985 and the Exports(as % of merchandise exports) of New Zealand in 1988?
Give a very brief answer. -24.72. What is the difference between the Exports(as % of merchandise exports) in El Salvador in 1985 and the Exports(as % of merchandise exports) in Israel in 1988?
Your answer should be very brief. -1.12. What is the difference between the Exports(as % of merchandise exports) in El Salvador in 1985 and the Exports(as % of merchandise exports) in New Zealand in 1988?
Make the answer very short. -22.89. What is the difference between the Exports(as % of merchandise exports) in Israel in 1985 and the Exports(as % of merchandise exports) in New Zealand in 1988?
Keep it short and to the point. -21.71. What is the difference between the Exports(as % of merchandise exports) of Caribbean small states in 1986 and the Exports(as % of merchandise exports) of El Salvador in 1987?
Make the answer very short. -2.73. What is the difference between the Exports(as % of merchandise exports) in Caribbean small states in 1986 and the Exports(as % of merchandise exports) in Israel in 1987?
Provide a short and direct response. -3.06. What is the difference between the Exports(as % of merchandise exports) of Caribbean small states in 1986 and the Exports(as % of merchandise exports) of New Zealand in 1987?
Provide a short and direct response. -23.75. What is the difference between the Exports(as % of merchandise exports) in El Salvador in 1986 and the Exports(as % of merchandise exports) in Israel in 1987?
Make the answer very short. -1.77. What is the difference between the Exports(as % of merchandise exports) of El Salvador in 1986 and the Exports(as % of merchandise exports) of New Zealand in 1987?
Your answer should be compact. -22.47. What is the difference between the Exports(as % of merchandise exports) in Israel in 1986 and the Exports(as % of merchandise exports) in New Zealand in 1987?
Provide a succinct answer. -20.38. What is the difference between the Exports(as % of merchandise exports) in Caribbean small states in 1986 and the Exports(as % of merchandise exports) in El Salvador in 1988?
Make the answer very short. -0.46. What is the difference between the Exports(as % of merchandise exports) of Caribbean small states in 1986 and the Exports(as % of merchandise exports) of Israel in 1988?
Your response must be concise. -2.94. What is the difference between the Exports(as % of merchandise exports) of Caribbean small states in 1986 and the Exports(as % of merchandise exports) of New Zealand in 1988?
Keep it short and to the point. -24.71. What is the difference between the Exports(as % of merchandise exports) in El Salvador in 1986 and the Exports(as % of merchandise exports) in Israel in 1988?
Ensure brevity in your answer.  -1.65. What is the difference between the Exports(as % of merchandise exports) of El Salvador in 1986 and the Exports(as % of merchandise exports) of New Zealand in 1988?
Your answer should be compact. -23.42. What is the difference between the Exports(as % of merchandise exports) of Israel in 1986 and the Exports(as % of merchandise exports) of New Zealand in 1988?
Make the answer very short. -21.34. What is the difference between the Exports(as % of merchandise exports) of Caribbean small states in 1987 and the Exports(as % of merchandise exports) of El Salvador in 1988?
Offer a very short reply. -0.38. What is the difference between the Exports(as % of merchandise exports) of Caribbean small states in 1987 and the Exports(as % of merchandise exports) of Israel in 1988?
Make the answer very short. -2.87. What is the difference between the Exports(as % of merchandise exports) in Caribbean small states in 1987 and the Exports(as % of merchandise exports) in New Zealand in 1988?
Provide a succinct answer. -24.64. What is the difference between the Exports(as % of merchandise exports) in El Salvador in 1987 and the Exports(as % of merchandise exports) in Israel in 1988?
Make the answer very short. -0.21. What is the difference between the Exports(as % of merchandise exports) in El Salvador in 1987 and the Exports(as % of merchandise exports) in New Zealand in 1988?
Ensure brevity in your answer.  -21.98. What is the difference between the Exports(as % of merchandise exports) of Israel in 1987 and the Exports(as % of merchandise exports) of New Zealand in 1988?
Provide a short and direct response. -21.65. What is the average Exports(as % of merchandise exports) of Caribbean small states per year?
Offer a terse response. 0.15. What is the average Exports(as % of merchandise exports) of El Salvador per year?
Your answer should be compact. 5.61. What is the average Exports(as % of merchandise exports) in Israel per year?
Ensure brevity in your answer.  3.9. What is the average Exports(as % of merchandise exports) of New Zealand per year?
Provide a succinct answer. 22.22. In the year 1981, what is the difference between the Exports(as % of merchandise exports) of Caribbean small states and Exports(as % of merchandise exports) of El Salvador?
Your answer should be very brief. -11.63. In the year 1981, what is the difference between the Exports(as % of merchandise exports) in Caribbean small states and Exports(as % of merchandise exports) in Israel?
Make the answer very short. -4.11. In the year 1981, what is the difference between the Exports(as % of merchandise exports) in Caribbean small states and Exports(as % of merchandise exports) in New Zealand?
Offer a terse response. -22.8. In the year 1981, what is the difference between the Exports(as % of merchandise exports) of El Salvador and Exports(as % of merchandise exports) of Israel?
Give a very brief answer. 7.52. In the year 1981, what is the difference between the Exports(as % of merchandise exports) in El Salvador and Exports(as % of merchandise exports) in New Zealand?
Your answer should be compact. -11.17. In the year 1981, what is the difference between the Exports(as % of merchandise exports) of Israel and Exports(as % of merchandise exports) of New Zealand?
Your response must be concise. -18.69. In the year 1982, what is the difference between the Exports(as % of merchandise exports) of Caribbean small states and Exports(as % of merchandise exports) of El Salvador?
Ensure brevity in your answer.  -11.46. In the year 1982, what is the difference between the Exports(as % of merchandise exports) of Caribbean small states and Exports(as % of merchandise exports) of Israel?
Provide a succinct answer. -4.32. In the year 1982, what is the difference between the Exports(as % of merchandise exports) in Caribbean small states and Exports(as % of merchandise exports) in New Zealand?
Offer a very short reply. -20.66. In the year 1982, what is the difference between the Exports(as % of merchandise exports) in El Salvador and Exports(as % of merchandise exports) in Israel?
Your answer should be very brief. 7.15. In the year 1982, what is the difference between the Exports(as % of merchandise exports) of El Salvador and Exports(as % of merchandise exports) of New Zealand?
Provide a short and direct response. -9.19. In the year 1982, what is the difference between the Exports(as % of merchandise exports) of Israel and Exports(as % of merchandise exports) of New Zealand?
Provide a succinct answer. -16.34. In the year 1983, what is the difference between the Exports(as % of merchandise exports) of Caribbean small states and Exports(as % of merchandise exports) of El Salvador?
Offer a terse response. -12.73. In the year 1983, what is the difference between the Exports(as % of merchandise exports) in Caribbean small states and Exports(as % of merchandise exports) in Israel?
Make the answer very short. -4.54. In the year 1983, what is the difference between the Exports(as % of merchandise exports) in Caribbean small states and Exports(as % of merchandise exports) in New Zealand?
Your answer should be compact. -21.41. In the year 1983, what is the difference between the Exports(as % of merchandise exports) of El Salvador and Exports(as % of merchandise exports) of Israel?
Offer a very short reply. 8.19. In the year 1983, what is the difference between the Exports(as % of merchandise exports) in El Salvador and Exports(as % of merchandise exports) in New Zealand?
Make the answer very short. -8.68. In the year 1983, what is the difference between the Exports(as % of merchandise exports) in Israel and Exports(as % of merchandise exports) in New Zealand?
Provide a succinct answer. -16.87. In the year 1984, what is the difference between the Exports(as % of merchandise exports) of Caribbean small states and Exports(as % of merchandise exports) of El Salvador?
Provide a short and direct response. -1.76. In the year 1984, what is the difference between the Exports(as % of merchandise exports) of Caribbean small states and Exports(as % of merchandise exports) of Israel?
Offer a very short reply. -4.86. In the year 1984, what is the difference between the Exports(as % of merchandise exports) in Caribbean small states and Exports(as % of merchandise exports) in New Zealand?
Your response must be concise. -20.78. In the year 1984, what is the difference between the Exports(as % of merchandise exports) in El Salvador and Exports(as % of merchandise exports) in Israel?
Your answer should be very brief. -3.1. In the year 1984, what is the difference between the Exports(as % of merchandise exports) of El Salvador and Exports(as % of merchandise exports) of New Zealand?
Make the answer very short. -19.02. In the year 1984, what is the difference between the Exports(as % of merchandise exports) of Israel and Exports(as % of merchandise exports) of New Zealand?
Provide a short and direct response. -15.92. In the year 1985, what is the difference between the Exports(as % of merchandise exports) in Caribbean small states and Exports(as % of merchandise exports) in El Salvador?
Your answer should be very brief. -1.83. In the year 1985, what is the difference between the Exports(as % of merchandise exports) of Caribbean small states and Exports(as % of merchandise exports) of Israel?
Your response must be concise. -3.01. In the year 1985, what is the difference between the Exports(as % of merchandise exports) in Caribbean small states and Exports(as % of merchandise exports) in New Zealand?
Your response must be concise. -20.66. In the year 1985, what is the difference between the Exports(as % of merchandise exports) in El Salvador and Exports(as % of merchandise exports) in Israel?
Keep it short and to the point. -1.18. In the year 1985, what is the difference between the Exports(as % of merchandise exports) of El Salvador and Exports(as % of merchandise exports) of New Zealand?
Your answer should be compact. -18.83. In the year 1985, what is the difference between the Exports(as % of merchandise exports) in Israel and Exports(as % of merchandise exports) in New Zealand?
Make the answer very short. -17.65. In the year 1986, what is the difference between the Exports(as % of merchandise exports) of Caribbean small states and Exports(as % of merchandise exports) of El Salvador?
Your response must be concise. -1.29. In the year 1986, what is the difference between the Exports(as % of merchandise exports) of Caribbean small states and Exports(as % of merchandise exports) of Israel?
Make the answer very short. -3.37. In the year 1986, what is the difference between the Exports(as % of merchandise exports) of Caribbean small states and Exports(as % of merchandise exports) of New Zealand?
Provide a short and direct response. -21.96. In the year 1986, what is the difference between the Exports(as % of merchandise exports) of El Salvador and Exports(as % of merchandise exports) of Israel?
Offer a terse response. -2.08. In the year 1986, what is the difference between the Exports(as % of merchandise exports) of El Salvador and Exports(as % of merchandise exports) of New Zealand?
Provide a succinct answer. -20.67. In the year 1986, what is the difference between the Exports(as % of merchandise exports) of Israel and Exports(as % of merchandise exports) of New Zealand?
Your response must be concise. -18.59. In the year 1987, what is the difference between the Exports(as % of merchandise exports) of Caribbean small states and Exports(as % of merchandise exports) of El Salvador?
Ensure brevity in your answer.  -2.66. In the year 1987, what is the difference between the Exports(as % of merchandise exports) of Caribbean small states and Exports(as % of merchandise exports) of Israel?
Your answer should be compact. -2.99. In the year 1987, what is the difference between the Exports(as % of merchandise exports) in Caribbean small states and Exports(as % of merchandise exports) in New Zealand?
Keep it short and to the point. -23.68. In the year 1987, what is the difference between the Exports(as % of merchandise exports) in El Salvador and Exports(as % of merchandise exports) in Israel?
Make the answer very short. -0.33. In the year 1987, what is the difference between the Exports(as % of merchandise exports) in El Salvador and Exports(as % of merchandise exports) in New Zealand?
Make the answer very short. -21.02. In the year 1987, what is the difference between the Exports(as % of merchandise exports) of Israel and Exports(as % of merchandise exports) of New Zealand?
Provide a succinct answer. -20.69. In the year 1988, what is the difference between the Exports(as % of merchandise exports) of Caribbean small states and Exports(as % of merchandise exports) of El Salvador?
Make the answer very short. -0.37. In the year 1988, what is the difference between the Exports(as % of merchandise exports) of Caribbean small states and Exports(as % of merchandise exports) of Israel?
Ensure brevity in your answer.  -2.85. In the year 1988, what is the difference between the Exports(as % of merchandise exports) of Caribbean small states and Exports(as % of merchandise exports) of New Zealand?
Your answer should be compact. -24.62. In the year 1988, what is the difference between the Exports(as % of merchandise exports) in El Salvador and Exports(as % of merchandise exports) in Israel?
Offer a very short reply. -2.48. In the year 1988, what is the difference between the Exports(as % of merchandise exports) in El Salvador and Exports(as % of merchandise exports) in New Zealand?
Offer a very short reply. -24.25. In the year 1988, what is the difference between the Exports(as % of merchandise exports) of Israel and Exports(as % of merchandise exports) of New Zealand?
Offer a terse response. -21.77. What is the ratio of the Exports(as % of merchandise exports) in Caribbean small states in 1981 to that in 1982?
Give a very brief answer. 0.7. What is the ratio of the Exports(as % of merchandise exports) of El Salvador in 1981 to that in 1982?
Offer a terse response. 1.01. What is the ratio of the Exports(as % of merchandise exports) in Israel in 1981 to that in 1982?
Ensure brevity in your answer.  0.94. What is the ratio of the Exports(as % of merchandise exports) of New Zealand in 1981 to that in 1982?
Provide a short and direct response. 1.1. What is the ratio of the Exports(as % of merchandise exports) in Caribbean small states in 1981 to that in 1983?
Keep it short and to the point. 1.09. What is the ratio of the Exports(as % of merchandise exports) of El Salvador in 1981 to that in 1983?
Your response must be concise. 0.91. What is the ratio of the Exports(as % of merchandise exports) of Israel in 1981 to that in 1983?
Offer a terse response. 0.91. What is the ratio of the Exports(as % of merchandise exports) of New Zealand in 1981 to that in 1983?
Offer a very short reply. 1.06. What is the ratio of the Exports(as % of merchandise exports) of Caribbean small states in 1981 to that in 1984?
Offer a terse response. 1.14. What is the ratio of the Exports(as % of merchandise exports) in El Salvador in 1981 to that in 1984?
Offer a terse response. 6.29. What is the ratio of the Exports(as % of merchandise exports) in Israel in 1981 to that in 1984?
Offer a terse response. 0.85. What is the ratio of the Exports(as % of merchandise exports) in New Zealand in 1981 to that in 1984?
Provide a short and direct response. 1.1. What is the ratio of the Exports(as % of merchandise exports) in Caribbean small states in 1981 to that in 1985?
Offer a terse response. 1.14. What is the ratio of the Exports(as % of merchandise exports) of El Salvador in 1981 to that in 1985?
Your answer should be compact. 6.05. What is the ratio of the Exports(as % of merchandise exports) in Israel in 1981 to that in 1985?
Your response must be concise. 1.36. What is the ratio of the Exports(as % of merchandise exports) in New Zealand in 1981 to that in 1985?
Make the answer very short. 1.1. What is the ratio of the Exports(as % of merchandise exports) in Caribbean small states in 1981 to that in 1986?
Offer a very short reply. 1.01. What is the ratio of the Exports(as % of merchandise exports) in El Salvador in 1981 to that in 1986?
Give a very brief answer. 8.31. What is the ratio of the Exports(as % of merchandise exports) of Israel in 1981 to that in 1986?
Make the answer very short. 1.21. What is the ratio of the Exports(as % of merchandise exports) in New Zealand in 1981 to that in 1986?
Offer a terse response. 1.04. What is the ratio of the Exports(as % of merchandise exports) of Caribbean small states in 1981 to that in 1987?
Offer a very short reply. 0.64. What is the ratio of the Exports(as % of merchandise exports) of El Salvador in 1981 to that in 1987?
Give a very brief answer. 4.11. What is the ratio of the Exports(as % of merchandise exports) of Israel in 1981 to that in 1987?
Ensure brevity in your answer.  1.33. What is the ratio of the Exports(as % of merchandise exports) in New Zealand in 1981 to that in 1987?
Your response must be concise. 0.96. What is the ratio of the Exports(as % of merchandise exports) of Caribbean small states in 1981 to that in 1988?
Your answer should be very brief. 0.6. What is the ratio of the Exports(as % of merchandise exports) in El Salvador in 1981 to that in 1988?
Offer a terse response. 20.24. What is the ratio of the Exports(as % of merchandise exports) in Israel in 1981 to that in 1988?
Make the answer very short. 1.38. What is the ratio of the Exports(as % of merchandise exports) of Caribbean small states in 1982 to that in 1983?
Give a very brief answer. 1.55. What is the ratio of the Exports(as % of merchandise exports) in El Salvador in 1982 to that in 1983?
Provide a short and direct response. 0.91. What is the ratio of the Exports(as % of merchandise exports) in Israel in 1982 to that in 1983?
Your response must be concise. 0.97. What is the ratio of the Exports(as % of merchandise exports) in New Zealand in 1982 to that in 1983?
Keep it short and to the point. 0.97. What is the ratio of the Exports(as % of merchandise exports) in Caribbean small states in 1982 to that in 1984?
Your response must be concise. 1.62. What is the ratio of the Exports(as % of merchandise exports) of El Salvador in 1982 to that in 1984?
Ensure brevity in your answer.  6.23. What is the ratio of the Exports(as % of merchandise exports) of Israel in 1982 to that in 1984?
Your answer should be very brief. 0.9. What is the ratio of the Exports(as % of merchandise exports) in Caribbean small states in 1982 to that in 1985?
Your answer should be very brief. 1.62. What is the ratio of the Exports(as % of merchandise exports) of El Salvador in 1982 to that in 1985?
Provide a succinct answer. 6. What is the ratio of the Exports(as % of merchandise exports) of Israel in 1982 to that in 1985?
Your response must be concise. 1.44. What is the ratio of the Exports(as % of merchandise exports) of Caribbean small states in 1982 to that in 1986?
Ensure brevity in your answer.  1.45. What is the ratio of the Exports(as % of merchandise exports) in El Salvador in 1982 to that in 1986?
Your answer should be very brief. 8.24. What is the ratio of the Exports(as % of merchandise exports) in Israel in 1982 to that in 1986?
Ensure brevity in your answer.  1.29. What is the ratio of the Exports(as % of merchandise exports) of New Zealand in 1982 to that in 1986?
Ensure brevity in your answer.  0.94. What is the ratio of the Exports(as % of merchandise exports) of Caribbean small states in 1982 to that in 1987?
Ensure brevity in your answer.  0.91. What is the ratio of the Exports(as % of merchandise exports) in El Salvador in 1982 to that in 1987?
Your response must be concise. 4.08. What is the ratio of the Exports(as % of merchandise exports) of Israel in 1982 to that in 1987?
Your answer should be very brief. 1.41. What is the ratio of the Exports(as % of merchandise exports) of New Zealand in 1982 to that in 1987?
Make the answer very short. 0.87. What is the ratio of the Exports(as % of merchandise exports) of Caribbean small states in 1982 to that in 1988?
Make the answer very short. 0.85. What is the ratio of the Exports(as % of merchandise exports) in El Salvador in 1982 to that in 1988?
Offer a terse response. 20.05. What is the ratio of the Exports(as % of merchandise exports) of Israel in 1982 to that in 1988?
Make the answer very short. 1.47. What is the ratio of the Exports(as % of merchandise exports) of New Zealand in 1982 to that in 1988?
Give a very brief answer. 0.84. What is the ratio of the Exports(as % of merchandise exports) of Caribbean small states in 1983 to that in 1984?
Make the answer very short. 1.05. What is the ratio of the Exports(as % of merchandise exports) in El Salvador in 1983 to that in 1984?
Your answer should be compact. 6.88. What is the ratio of the Exports(as % of merchandise exports) in Israel in 1983 to that in 1984?
Make the answer very short. 0.94. What is the ratio of the Exports(as % of merchandise exports) in New Zealand in 1983 to that in 1984?
Your response must be concise. 1.03. What is the ratio of the Exports(as % of merchandise exports) of Caribbean small states in 1983 to that in 1985?
Keep it short and to the point. 1.04. What is the ratio of the Exports(as % of merchandise exports) of El Salvador in 1983 to that in 1985?
Your answer should be very brief. 6.62. What is the ratio of the Exports(as % of merchandise exports) in Israel in 1983 to that in 1985?
Offer a terse response. 1.49. What is the ratio of the Exports(as % of merchandise exports) of New Zealand in 1983 to that in 1985?
Your response must be concise. 1.04. What is the ratio of the Exports(as % of merchandise exports) in Caribbean small states in 1983 to that in 1986?
Your response must be concise. 0.93. What is the ratio of the Exports(as % of merchandise exports) of El Salvador in 1983 to that in 1986?
Offer a terse response. 9.09. What is the ratio of the Exports(as % of merchandise exports) of Israel in 1983 to that in 1986?
Your answer should be very brief. 1.33. What is the ratio of the Exports(as % of merchandise exports) in New Zealand in 1983 to that in 1986?
Offer a terse response. 0.97. What is the ratio of the Exports(as % of merchandise exports) of Caribbean small states in 1983 to that in 1987?
Ensure brevity in your answer.  0.59. What is the ratio of the Exports(as % of merchandise exports) in El Salvador in 1983 to that in 1987?
Give a very brief answer. 4.5. What is the ratio of the Exports(as % of merchandise exports) in Israel in 1983 to that in 1987?
Offer a very short reply. 1.46. What is the ratio of the Exports(as % of merchandise exports) of New Zealand in 1983 to that in 1987?
Give a very brief answer. 0.9. What is the ratio of the Exports(as % of merchandise exports) of Caribbean small states in 1983 to that in 1988?
Provide a short and direct response. 0.55. What is the ratio of the Exports(as % of merchandise exports) in El Salvador in 1983 to that in 1988?
Your response must be concise. 22.12. What is the ratio of the Exports(as % of merchandise exports) of Israel in 1983 to that in 1988?
Your answer should be compact. 1.52. What is the ratio of the Exports(as % of merchandise exports) of New Zealand in 1983 to that in 1988?
Ensure brevity in your answer.  0.87. What is the ratio of the Exports(as % of merchandise exports) of Caribbean small states in 1984 to that in 1985?
Offer a terse response. 1. What is the ratio of the Exports(as % of merchandise exports) of El Salvador in 1984 to that in 1985?
Give a very brief answer. 0.96. What is the ratio of the Exports(as % of merchandise exports) in Israel in 1984 to that in 1985?
Your answer should be very brief. 1.59. What is the ratio of the Exports(as % of merchandise exports) in New Zealand in 1984 to that in 1985?
Make the answer very short. 1.01. What is the ratio of the Exports(as % of merchandise exports) in Caribbean small states in 1984 to that in 1986?
Make the answer very short. 0.89. What is the ratio of the Exports(as % of merchandise exports) in El Salvador in 1984 to that in 1986?
Keep it short and to the point. 1.32. What is the ratio of the Exports(as % of merchandise exports) of Israel in 1984 to that in 1986?
Your answer should be compact. 1.42. What is the ratio of the Exports(as % of merchandise exports) of New Zealand in 1984 to that in 1986?
Provide a short and direct response. 0.95. What is the ratio of the Exports(as % of merchandise exports) in Caribbean small states in 1984 to that in 1987?
Your response must be concise. 0.56. What is the ratio of the Exports(as % of merchandise exports) in El Salvador in 1984 to that in 1987?
Ensure brevity in your answer.  0.65. What is the ratio of the Exports(as % of merchandise exports) in Israel in 1984 to that in 1987?
Your answer should be very brief. 1.56. What is the ratio of the Exports(as % of merchandise exports) in New Zealand in 1984 to that in 1987?
Offer a terse response. 0.87. What is the ratio of the Exports(as % of merchandise exports) in Caribbean small states in 1984 to that in 1988?
Keep it short and to the point. 0.53. What is the ratio of the Exports(as % of merchandise exports) in El Salvador in 1984 to that in 1988?
Make the answer very short. 3.22. What is the ratio of the Exports(as % of merchandise exports) in Israel in 1984 to that in 1988?
Provide a short and direct response. 1.62. What is the ratio of the Exports(as % of merchandise exports) of New Zealand in 1984 to that in 1988?
Give a very brief answer. 0.84. What is the ratio of the Exports(as % of merchandise exports) in Caribbean small states in 1985 to that in 1986?
Offer a terse response. 0.89. What is the ratio of the Exports(as % of merchandise exports) of El Salvador in 1985 to that in 1986?
Give a very brief answer. 1.37. What is the ratio of the Exports(as % of merchandise exports) of Israel in 1985 to that in 1986?
Your answer should be compact. 0.89. What is the ratio of the Exports(as % of merchandise exports) of New Zealand in 1985 to that in 1986?
Offer a very short reply. 0.94. What is the ratio of the Exports(as % of merchandise exports) of Caribbean small states in 1985 to that in 1987?
Offer a terse response. 0.56. What is the ratio of the Exports(as % of merchandise exports) of El Salvador in 1985 to that in 1987?
Make the answer very short. 0.68. What is the ratio of the Exports(as % of merchandise exports) in Israel in 1985 to that in 1987?
Give a very brief answer. 0.98. What is the ratio of the Exports(as % of merchandise exports) of New Zealand in 1985 to that in 1987?
Give a very brief answer. 0.87. What is the ratio of the Exports(as % of merchandise exports) of Caribbean small states in 1985 to that in 1988?
Give a very brief answer. 0.53. What is the ratio of the Exports(as % of merchandise exports) in El Salvador in 1985 to that in 1988?
Your answer should be very brief. 3.34. What is the ratio of the Exports(as % of merchandise exports) of Israel in 1985 to that in 1988?
Provide a short and direct response. 1.02. What is the ratio of the Exports(as % of merchandise exports) in New Zealand in 1985 to that in 1988?
Provide a short and direct response. 0.84. What is the ratio of the Exports(as % of merchandise exports) of Caribbean small states in 1986 to that in 1987?
Keep it short and to the point. 0.63. What is the ratio of the Exports(as % of merchandise exports) in El Salvador in 1986 to that in 1987?
Provide a short and direct response. 0.49. What is the ratio of the Exports(as % of merchandise exports) of Israel in 1986 to that in 1987?
Offer a very short reply. 1.1. What is the ratio of the Exports(as % of merchandise exports) in New Zealand in 1986 to that in 1987?
Provide a succinct answer. 0.93. What is the ratio of the Exports(as % of merchandise exports) of Caribbean small states in 1986 to that in 1988?
Your response must be concise. 0.59. What is the ratio of the Exports(as % of merchandise exports) of El Salvador in 1986 to that in 1988?
Keep it short and to the point. 2.43. What is the ratio of the Exports(as % of merchandise exports) of Israel in 1986 to that in 1988?
Keep it short and to the point. 1.14. What is the ratio of the Exports(as % of merchandise exports) in New Zealand in 1986 to that in 1988?
Offer a terse response. 0.89. What is the ratio of the Exports(as % of merchandise exports) of Caribbean small states in 1987 to that in 1988?
Your response must be concise. 0.94. What is the ratio of the Exports(as % of merchandise exports) of El Salvador in 1987 to that in 1988?
Give a very brief answer. 4.92. What is the ratio of the Exports(as % of merchandise exports) of Israel in 1987 to that in 1988?
Your answer should be very brief. 1.04. What is the ratio of the Exports(as % of merchandise exports) of New Zealand in 1987 to that in 1988?
Offer a terse response. 0.96. What is the difference between the highest and the second highest Exports(as % of merchandise exports) in Caribbean small states?
Provide a short and direct response. 0.01. What is the difference between the highest and the second highest Exports(as % of merchandise exports) in El Salvador?
Make the answer very short. 1.09. What is the difference between the highest and the second highest Exports(as % of merchandise exports) of Israel?
Offer a very short reply. 0.31. What is the difference between the highest and the second highest Exports(as % of merchandise exports) in New Zealand?
Make the answer very short. 0.95. What is the difference between the highest and the lowest Exports(as % of merchandise exports) in Caribbean small states?
Provide a short and direct response. 0.1. What is the difference between the highest and the lowest Exports(as % of merchandise exports) of El Salvador?
Provide a succinct answer. 12.27. What is the difference between the highest and the lowest Exports(as % of merchandise exports) in Israel?
Provide a succinct answer. 1.91. What is the difference between the highest and the lowest Exports(as % of merchandise exports) in New Zealand?
Offer a terse response. 4.06. 